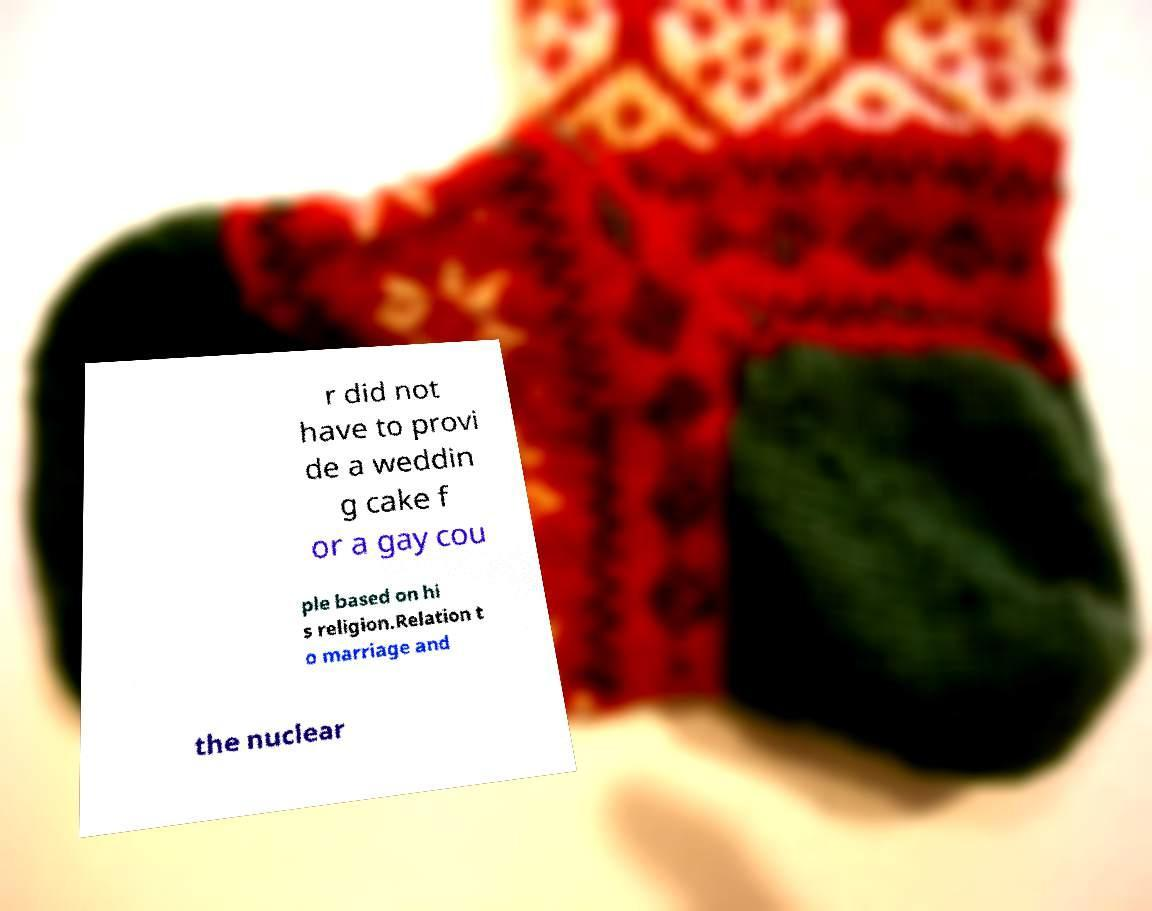Could you assist in decoding the text presented in this image and type it out clearly? r did not have to provi de a weddin g cake f or a gay cou ple based on hi s religion.Relation t o marriage and the nuclear 